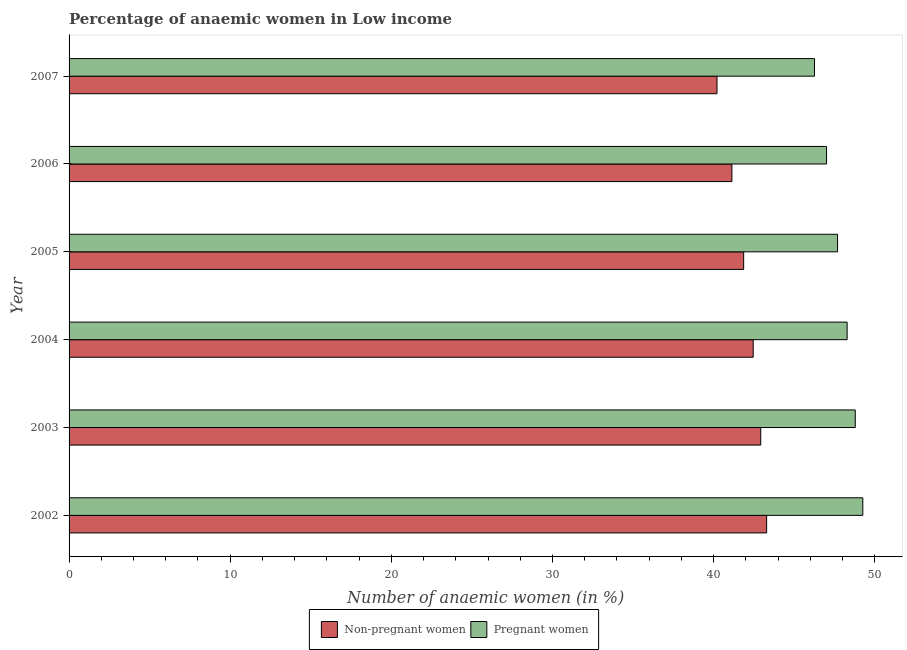How many groups of bars are there?
Offer a very short reply. 6. Are the number of bars on each tick of the Y-axis equal?
Keep it short and to the point. Yes. How many bars are there on the 5th tick from the top?
Your response must be concise. 2. How many bars are there on the 3rd tick from the bottom?
Make the answer very short. 2. What is the percentage of pregnant anaemic women in 2004?
Your response must be concise. 48.28. Across all years, what is the maximum percentage of pregnant anaemic women?
Provide a succinct answer. 49.26. Across all years, what is the minimum percentage of non-pregnant anaemic women?
Provide a succinct answer. 40.21. In which year was the percentage of non-pregnant anaemic women minimum?
Offer a terse response. 2007. What is the total percentage of non-pregnant anaemic women in the graph?
Offer a terse response. 251.87. What is the difference between the percentage of non-pregnant anaemic women in 2005 and that in 2007?
Give a very brief answer. 1.66. What is the difference between the percentage of non-pregnant anaemic women in 2002 and the percentage of pregnant anaemic women in 2007?
Make the answer very short. -2.97. What is the average percentage of non-pregnant anaemic women per year?
Your answer should be compact. 41.98. In the year 2004, what is the difference between the percentage of pregnant anaemic women and percentage of non-pregnant anaemic women?
Provide a succinct answer. 5.83. What is the ratio of the percentage of non-pregnant anaemic women in 2004 to that in 2007?
Your answer should be very brief. 1.06. What is the difference between the highest and the second highest percentage of non-pregnant anaemic women?
Keep it short and to the point. 0.36. What is the difference between the highest and the lowest percentage of non-pregnant anaemic women?
Provide a short and direct response. 3.08. What does the 2nd bar from the top in 2006 represents?
Provide a succinct answer. Non-pregnant women. What does the 1st bar from the bottom in 2005 represents?
Your answer should be very brief. Non-pregnant women. How many bars are there?
Offer a very short reply. 12. How many years are there in the graph?
Offer a terse response. 6. Are the values on the major ticks of X-axis written in scientific E-notation?
Your response must be concise. No. Where does the legend appear in the graph?
Your answer should be compact. Bottom center. How are the legend labels stacked?
Ensure brevity in your answer.  Horizontal. What is the title of the graph?
Your answer should be very brief. Percentage of anaemic women in Low income. What is the label or title of the X-axis?
Your answer should be compact. Number of anaemic women (in %). What is the label or title of the Y-axis?
Make the answer very short. Year. What is the Number of anaemic women (in %) of Non-pregnant women in 2002?
Give a very brief answer. 43.29. What is the Number of anaemic women (in %) in Pregnant women in 2002?
Your answer should be very brief. 49.26. What is the Number of anaemic women (in %) in Non-pregnant women in 2003?
Make the answer very short. 42.92. What is the Number of anaemic women (in %) in Pregnant women in 2003?
Offer a terse response. 48.79. What is the Number of anaemic women (in %) in Non-pregnant women in 2004?
Your response must be concise. 42.46. What is the Number of anaemic women (in %) in Pregnant women in 2004?
Your answer should be compact. 48.28. What is the Number of anaemic women (in %) in Non-pregnant women in 2005?
Give a very brief answer. 41.86. What is the Number of anaemic women (in %) of Pregnant women in 2005?
Your response must be concise. 47.69. What is the Number of anaemic women (in %) in Non-pregnant women in 2006?
Keep it short and to the point. 41.13. What is the Number of anaemic women (in %) of Pregnant women in 2006?
Your answer should be very brief. 47.01. What is the Number of anaemic women (in %) in Non-pregnant women in 2007?
Your response must be concise. 40.21. What is the Number of anaemic women (in %) of Pregnant women in 2007?
Your response must be concise. 46.26. Across all years, what is the maximum Number of anaemic women (in %) of Non-pregnant women?
Your response must be concise. 43.29. Across all years, what is the maximum Number of anaemic women (in %) in Pregnant women?
Offer a very short reply. 49.26. Across all years, what is the minimum Number of anaemic women (in %) in Non-pregnant women?
Provide a short and direct response. 40.21. Across all years, what is the minimum Number of anaemic women (in %) in Pregnant women?
Your answer should be very brief. 46.26. What is the total Number of anaemic women (in %) in Non-pregnant women in the graph?
Provide a short and direct response. 251.87. What is the total Number of anaemic women (in %) in Pregnant women in the graph?
Provide a short and direct response. 287.29. What is the difference between the Number of anaemic women (in %) in Non-pregnant women in 2002 and that in 2003?
Offer a very short reply. 0.37. What is the difference between the Number of anaemic women (in %) of Pregnant women in 2002 and that in 2003?
Ensure brevity in your answer.  0.47. What is the difference between the Number of anaemic women (in %) of Pregnant women in 2002 and that in 2004?
Offer a very short reply. 0.97. What is the difference between the Number of anaemic women (in %) of Non-pregnant women in 2002 and that in 2005?
Give a very brief answer. 1.43. What is the difference between the Number of anaemic women (in %) in Pregnant women in 2002 and that in 2005?
Make the answer very short. 1.57. What is the difference between the Number of anaemic women (in %) of Non-pregnant women in 2002 and that in 2006?
Make the answer very short. 2.15. What is the difference between the Number of anaemic women (in %) in Pregnant women in 2002 and that in 2006?
Make the answer very short. 2.25. What is the difference between the Number of anaemic women (in %) of Non-pregnant women in 2002 and that in 2007?
Ensure brevity in your answer.  3.08. What is the difference between the Number of anaemic women (in %) of Pregnant women in 2002 and that in 2007?
Your answer should be compact. 3. What is the difference between the Number of anaemic women (in %) of Non-pregnant women in 2003 and that in 2004?
Keep it short and to the point. 0.47. What is the difference between the Number of anaemic women (in %) of Pregnant women in 2003 and that in 2004?
Provide a succinct answer. 0.5. What is the difference between the Number of anaemic women (in %) of Non-pregnant women in 2003 and that in 2005?
Offer a terse response. 1.06. What is the difference between the Number of anaemic women (in %) of Pregnant women in 2003 and that in 2005?
Give a very brief answer. 1.1. What is the difference between the Number of anaemic women (in %) in Non-pregnant women in 2003 and that in 2006?
Your response must be concise. 1.79. What is the difference between the Number of anaemic women (in %) of Pregnant women in 2003 and that in 2006?
Offer a terse response. 1.78. What is the difference between the Number of anaemic women (in %) of Non-pregnant women in 2003 and that in 2007?
Your response must be concise. 2.71. What is the difference between the Number of anaemic women (in %) in Pregnant women in 2003 and that in 2007?
Offer a terse response. 2.53. What is the difference between the Number of anaemic women (in %) of Non-pregnant women in 2004 and that in 2005?
Your answer should be compact. 0.59. What is the difference between the Number of anaemic women (in %) of Pregnant women in 2004 and that in 2005?
Provide a short and direct response. 0.59. What is the difference between the Number of anaemic women (in %) of Non-pregnant women in 2004 and that in 2006?
Offer a terse response. 1.32. What is the difference between the Number of anaemic women (in %) of Pregnant women in 2004 and that in 2006?
Your answer should be compact. 1.28. What is the difference between the Number of anaemic women (in %) in Non-pregnant women in 2004 and that in 2007?
Make the answer very short. 2.25. What is the difference between the Number of anaemic women (in %) in Pregnant women in 2004 and that in 2007?
Provide a succinct answer. 2.03. What is the difference between the Number of anaemic women (in %) in Non-pregnant women in 2005 and that in 2006?
Offer a very short reply. 0.73. What is the difference between the Number of anaemic women (in %) of Pregnant women in 2005 and that in 2006?
Your response must be concise. 0.68. What is the difference between the Number of anaemic women (in %) of Non-pregnant women in 2005 and that in 2007?
Ensure brevity in your answer.  1.65. What is the difference between the Number of anaemic women (in %) in Pregnant women in 2005 and that in 2007?
Provide a succinct answer. 1.43. What is the difference between the Number of anaemic women (in %) of Non-pregnant women in 2006 and that in 2007?
Make the answer very short. 0.93. What is the difference between the Number of anaemic women (in %) of Pregnant women in 2006 and that in 2007?
Provide a short and direct response. 0.75. What is the difference between the Number of anaemic women (in %) of Non-pregnant women in 2002 and the Number of anaemic women (in %) of Pregnant women in 2003?
Provide a short and direct response. -5.5. What is the difference between the Number of anaemic women (in %) in Non-pregnant women in 2002 and the Number of anaemic women (in %) in Pregnant women in 2004?
Give a very brief answer. -5. What is the difference between the Number of anaemic women (in %) in Non-pregnant women in 2002 and the Number of anaemic women (in %) in Pregnant women in 2005?
Offer a very short reply. -4.4. What is the difference between the Number of anaemic women (in %) in Non-pregnant women in 2002 and the Number of anaemic women (in %) in Pregnant women in 2006?
Offer a terse response. -3.72. What is the difference between the Number of anaemic women (in %) in Non-pregnant women in 2002 and the Number of anaemic women (in %) in Pregnant women in 2007?
Provide a succinct answer. -2.97. What is the difference between the Number of anaemic women (in %) in Non-pregnant women in 2003 and the Number of anaemic women (in %) in Pregnant women in 2004?
Give a very brief answer. -5.36. What is the difference between the Number of anaemic women (in %) of Non-pregnant women in 2003 and the Number of anaemic women (in %) of Pregnant women in 2005?
Provide a succinct answer. -4.77. What is the difference between the Number of anaemic women (in %) in Non-pregnant women in 2003 and the Number of anaemic women (in %) in Pregnant women in 2006?
Your answer should be compact. -4.08. What is the difference between the Number of anaemic women (in %) in Non-pregnant women in 2003 and the Number of anaemic women (in %) in Pregnant women in 2007?
Ensure brevity in your answer.  -3.33. What is the difference between the Number of anaemic women (in %) in Non-pregnant women in 2004 and the Number of anaemic women (in %) in Pregnant women in 2005?
Make the answer very short. -5.24. What is the difference between the Number of anaemic women (in %) in Non-pregnant women in 2004 and the Number of anaemic women (in %) in Pregnant women in 2006?
Your answer should be compact. -4.55. What is the difference between the Number of anaemic women (in %) in Non-pregnant women in 2004 and the Number of anaemic women (in %) in Pregnant women in 2007?
Give a very brief answer. -3.8. What is the difference between the Number of anaemic women (in %) of Non-pregnant women in 2005 and the Number of anaemic women (in %) of Pregnant women in 2006?
Your answer should be compact. -5.14. What is the difference between the Number of anaemic women (in %) in Non-pregnant women in 2005 and the Number of anaemic women (in %) in Pregnant women in 2007?
Give a very brief answer. -4.4. What is the difference between the Number of anaemic women (in %) of Non-pregnant women in 2006 and the Number of anaemic women (in %) of Pregnant women in 2007?
Your answer should be very brief. -5.12. What is the average Number of anaemic women (in %) in Non-pregnant women per year?
Offer a terse response. 41.98. What is the average Number of anaemic women (in %) of Pregnant women per year?
Make the answer very short. 47.88. In the year 2002, what is the difference between the Number of anaemic women (in %) of Non-pregnant women and Number of anaemic women (in %) of Pregnant women?
Provide a succinct answer. -5.97. In the year 2003, what is the difference between the Number of anaemic women (in %) of Non-pregnant women and Number of anaemic women (in %) of Pregnant women?
Offer a very short reply. -5.87. In the year 2004, what is the difference between the Number of anaemic women (in %) of Non-pregnant women and Number of anaemic women (in %) of Pregnant women?
Provide a short and direct response. -5.83. In the year 2005, what is the difference between the Number of anaemic women (in %) in Non-pregnant women and Number of anaemic women (in %) in Pregnant women?
Make the answer very short. -5.83. In the year 2006, what is the difference between the Number of anaemic women (in %) of Non-pregnant women and Number of anaemic women (in %) of Pregnant women?
Provide a short and direct response. -5.87. In the year 2007, what is the difference between the Number of anaemic women (in %) in Non-pregnant women and Number of anaemic women (in %) in Pregnant women?
Keep it short and to the point. -6.05. What is the ratio of the Number of anaemic women (in %) in Non-pregnant women in 2002 to that in 2003?
Make the answer very short. 1.01. What is the ratio of the Number of anaemic women (in %) of Pregnant women in 2002 to that in 2003?
Provide a succinct answer. 1.01. What is the ratio of the Number of anaemic women (in %) of Non-pregnant women in 2002 to that in 2004?
Your response must be concise. 1.02. What is the ratio of the Number of anaemic women (in %) of Pregnant women in 2002 to that in 2004?
Provide a succinct answer. 1.02. What is the ratio of the Number of anaemic women (in %) of Non-pregnant women in 2002 to that in 2005?
Ensure brevity in your answer.  1.03. What is the ratio of the Number of anaemic women (in %) of Pregnant women in 2002 to that in 2005?
Give a very brief answer. 1.03. What is the ratio of the Number of anaemic women (in %) in Non-pregnant women in 2002 to that in 2006?
Give a very brief answer. 1.05. What is the ratio of the Number of anaemic women (in %) in Pregnant women in 2002 to that in 2006?
Give a very brief answer. 1.05. What is the ratio of the Number of anaemic women (in %) in Non-pregnant women in 2002 to that in 2007?
Offer a very short reply. 1.08. What is the ratio of the Number of anaemic women (in %) in Pregnant women in 2002 to that in 2007?
Provide a succinct answer. 1.06. What is the ratio of the Number of anaemic women (in %) in Non-pregnant women in 2003 to that in 2004?
Your answer should be very brief. 1.01. What is the ratio of the Number of anaemic women (in %) of Pregnant women in 2003 to that in 2004?
Your answer should be compact. 1.01. What is the ratio of the Number of anaemic women (in %) of Non-pregnant women in 2003 to that in 2005?
Keep it short and to the point. 1.03. What is the ratio of the Number of anaemic women (in %) of Non-pregnant women in 2003 to that in 2006?
Offer a very short reply. 1.04. What is the ratio of the Number of anaemic women (in %) in Pregnant women in 2003 to that in 2006?
Keep it short and to the point. 1.04. What is the ratio of the Number of anaemic women (in %) of Non-pregnant women in 2003 to that in 2007?
Provide a short and direct response. 1.07. What is the ratio of the Number of anaemic women (in %) in Pregnant women in 2003 to that in 2007?
Offer a very short reply. 1.05. What is the ratio of the Number of anaemic women (in %) of Non-pregnant women in 2004 to that in 2005?
Offer a very short reply. 1.01. What is the ratio of the Number of anaemic women (in %) of Pregnant women in 2004 to that in 2005?
Make the answer very short. 1.01. What is the ratio of the Number of anaemic women (in %) of Non-pregnant women in 2004 to that in 2006?
Your answer should be very brief. 1.03. What is the ratio of the Number of anaemic women (in %) of Pregnant women in 2004 to that in 2006?
Your answer should be very brief. 1.03. What is the ratio of the Number of anaemic women (in %) of Non-pregnant women in 2004 to that in 2007?
Your response must be concise. 1.06. What is the ratio of the Number of anaemic women (in %) of Pregnant women in 2004 to that in 2007?
Your answer should be very brief. 1.04. What is the ratio of the Number of anaemic women (in %) of Non-pregnant women in 2005 to that in 2006?
Your answer should be compact. 1.02. What is the ratio of the Number of anaemic women (in %) of Pregnant women in 2005 to that in 2006?
Ensure brevity in your answer.  1.01. What is the ratio of the Number of anaemic women (in %) of Non-pregnant women in 2005 to that in 2007?
Offer a terse response. 1.04. What is the ratio of the Number of anaemic women (in %) of Pregnant women in 2005 to that in 2007?
Make the answer very short. 1.03. What is the ratio of the Number of anaemic women (in %) of Non-pregnant women in 2006 to that in 2007?
Provide a short and direct response. 1.02. What is the ratio of the Number of anaemic women (in %) in Pregnant women in 2006 to that in 2007?
Give a very brief answer. 1.02. What is the difference between the highest and the second highest Number of anaemic women (in %) of Non-pregnant women?
Keep it short and to the point. 0.37. What is the difference between the highest and the second highest Number of anaemic women (in %) in Pregnant women?
Your response must be concise. 0.47. What is the difference between the highest and the lowest Number of anaemic women (in %) of Non-pregnant women?
Provide a succinct answer. 3.08. What is the difference between the highest and the lowest Number of anaemic women (in %) in Pregnant women?
Provide a short and direct response. 3. 